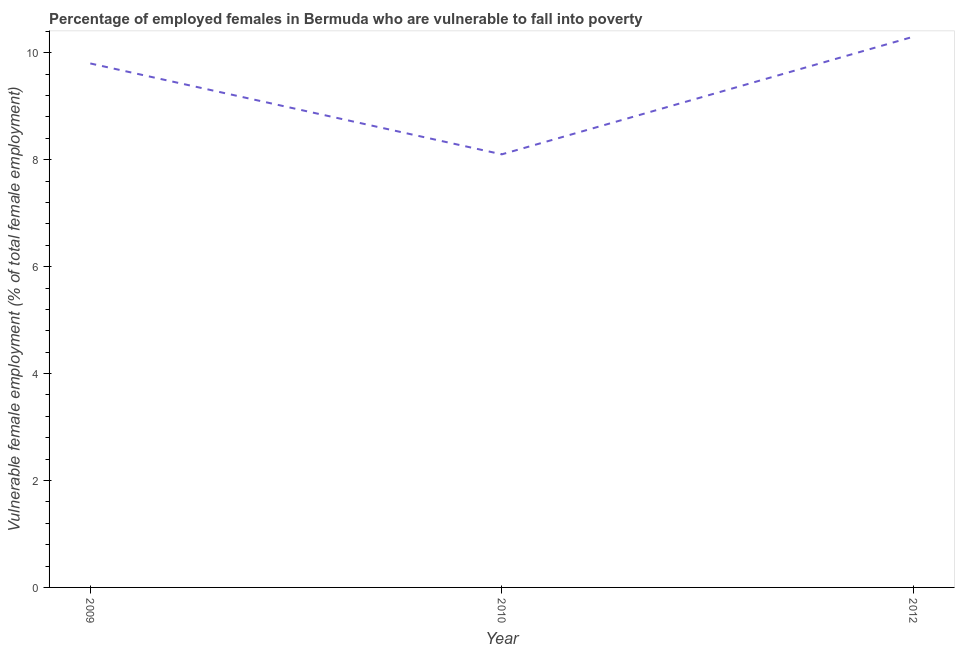What is the percentage of employed females who are vulnerable to fall into poverty in 2009?
Provide a short and direct response. 9.8. Across all years, what is the maximum percentage of employed females who are vulnerable to fall into poverty?
Keep it short and to the point. 10.3. Across all years, what is the minimum percentage of employed females who are vulnerable to fall into poverty?
Your answer should be very brief. 8.1. In which year was the percentage of employed females who are vulnerable to fall into poverty maximum?
Ensure brevity in your answer.  2012. In which year was the percentage of employed females who are vulnerable to fall into poverty minimum?
Your answer should be very brief. 2010. What is the sum of the percentage of employed females who are vulnerable to fall into poverty?
Keep it short and to the point. 28.2. What is the difference between the percentage of employed females who are vulnerable to fall into poverty in 2009 and 2010?
Your response must be concise. 1.7. What is the average percentage of employed females who are vulnerable to fall into poverty per year?
Offer a very short reply. 9.4. What is the median percentage of employed females who are vulnerable to fall into poverty?
Offer a terse response. 9.8. What is the ratio of the percentage of employed females who are vulnerable to fall into poverty in 2010 to that in 2012?
Your response must be concise. 0.79. What is the difference between the highest and the second highest percentage of employed females who are vulnerable to fall into poverty?
Offer a terse response. 0.5. Is the sum of the percentage of employed females who are vulnerable to fall into poverty in 2009 and 2010 greater than the maximum percentage of employed females who are vulnerable to fall into poverty across all years?
Offer a terse response. Yes. What is the difference between the highest and the lowest percentage of employed females who are vulnerable to fall into poverty?
Keep it short and to the point. 2.2. How many lines are there?
Your response must be concise. 1. How many years are there in the graph?
Your answer should be compact. 3. What is the difference between two consecutive major ticks on the Y-axis?
Provide a succinct answer. 2. Are the values on the major ticks of Y-axis written in scientific E-notation?
Ensure brevity in your answer.  No. Does the graph contain any zero values?
Your answer should be very brief. No. What is the title of the graph?
Offer a very short reply. Percentage of employed females in Bermuda who are vulnerable to fall into poverty. What is the label or title of the Y-axis?
Your response must be concise. Vulnerable female employment (% of total female employment). What is the Vulnerable female employment (% of total female employment) in 2009?
Provide a succinct answer. 9.8. What is the Vulnerable female employment (% of total female employment) of 2010?
Make the answer very short. 8.1. What is the Vulnerable female employment (% of total female employment) in 2012?
Offer a very short reply. 10.3. What is the difference between the Vulnerable female employment (% of total female employment) in 2009 and 2012?
Your response must be concise. -0.5. What is the difference between the Vulnerable female employment (% of total female employment) in 2010 and 2012?
Offer a terse response. -2.2. What is the ratio of the Vulnerable female employment (% of total female employment) in 2009 to that in 2010?
Keep it short and to the point. 1.21. What is the ratio of the Vulnerable female employment (% of total female employment) in 2009 to that in 2012?
Make the answer very short. 0.95. What is the ratio of the Vulnerable female employment (% of total female employment) in 2010 to that in 2012?
Provide a short and direct response. 0.79. 